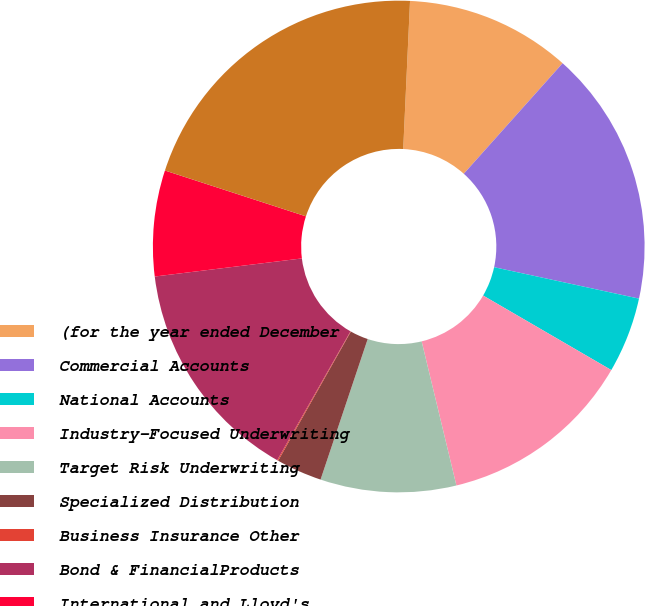Convert chart to OTSL. <chart><loc_0><loc_0><loc_500><loc_500><pie_chart><fcel>(for the year ended December<fcel>Commercial Accounts<fcel>National Accounts<fcel>Industry-Focused Underwriting<fcel>Target Risk Underwriting<fcel>Specialized Distribution<fcel>Business Insurance Other<fcel>Bond & FinancialProducts<fcel>International and Lloyd's<fcel>Total Financial Professional &<nl><fcel>10.88%<fcel>16.79%<fcel>4.98%<fcel>12.85%<fcel>8.92%<fcel>3.01%<fcel>0.07%<fcel>14.82%<fcel>6.95%<fcel>20.73%<nl></chart> 